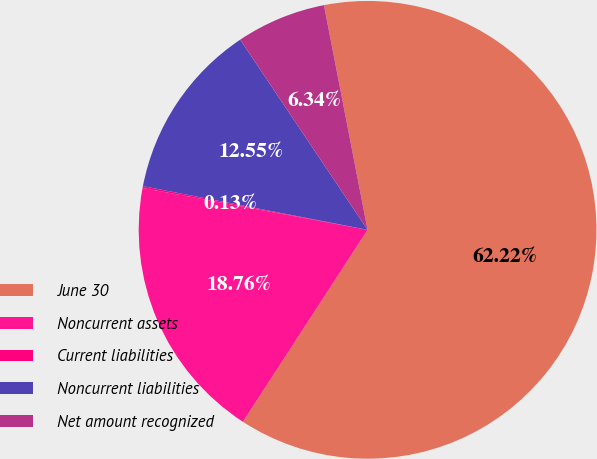Convert chart. <chart><loc_0><loc_0><loc_500><loc_500><pie_chart><fcel>June 30<fcel>Noncurrent assets<fcel>Current liabilities<fcel>Noncurrent liabilities<fcel>Net amount recognized<nl><fcel>62.22%<fcel>18.76%<fcel>0.13%<fcel>12.55%<fcel>6.34%<nl></chart> 